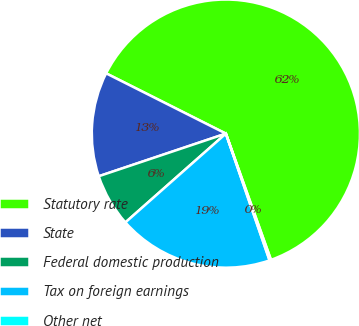Convert chart. <chart><loc_0><loc_0><loc_500><loc_500><pie_chart><fcel>Statutory rate<fcel>State<fcel>Federal domestic production<fcel>Tax on foreign earnings<fcel>Other net<nl><fcel>62.12%<fcel>12.57%<fcel>6.37%<fcel>18.76%<fcel>0.18%<nl></chart> 